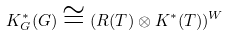<formula> <loc_0><loc_0><loc_500><loc_500>K ^ { * } _ { G } ( G ) \cong ( R ( T ) \otimes K ^ { * } ( T ) ) ^ { W }</formula> 